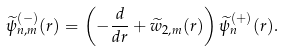<formula> <loc_0><loc_0><loc_500><loc_500>\widetilde { \psi } _ { n , m } ^ { ( - ) } ( r ) = \left ( - \frac { d } { d r } + { \widetilde { w } } _ { 2 , m } ( r ) \right ) \widetilde { \psi } ^ { ( + ) } _ { n } ( r ) .</formula> 